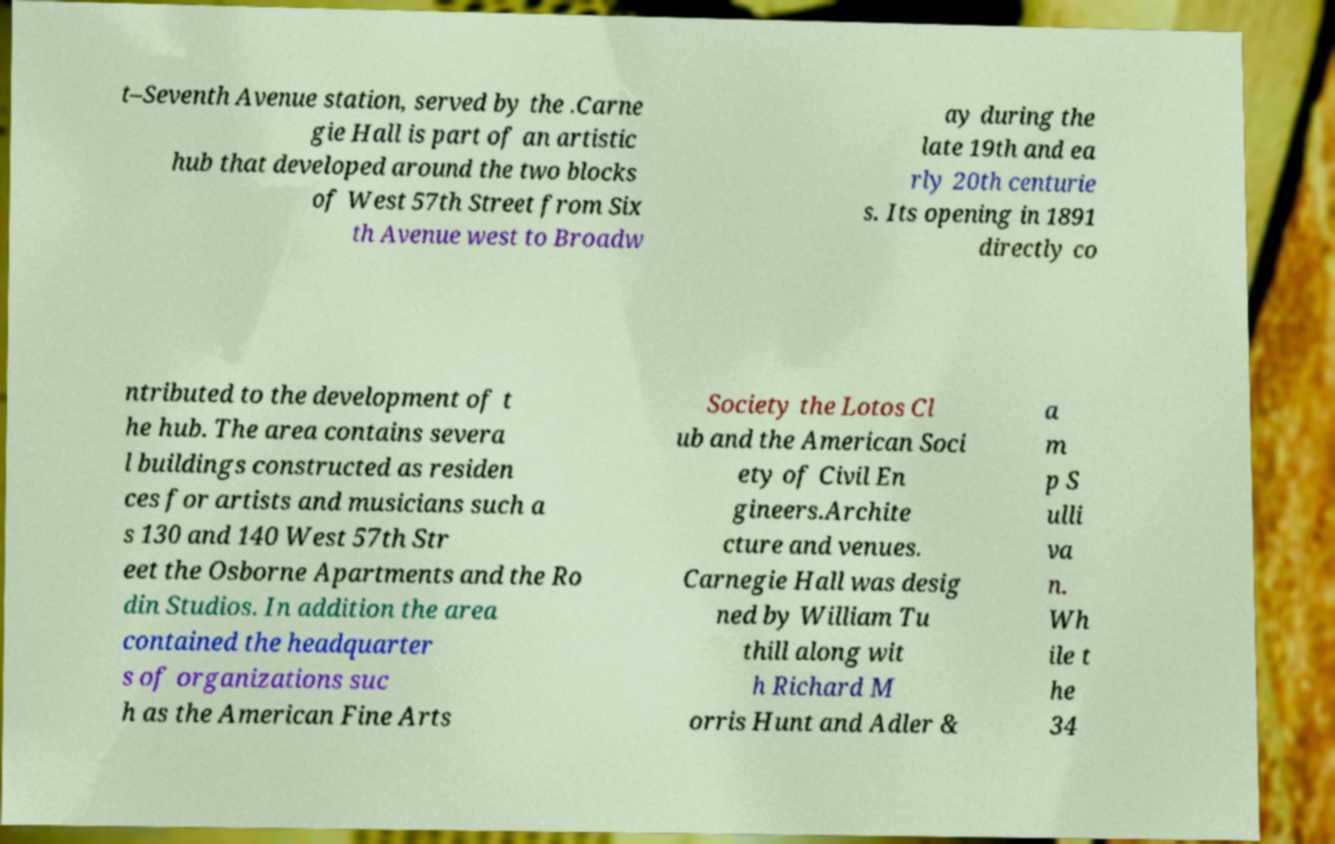Can you read and provide the text displayed in the image?This photo seems to have some interesting text. Can you extract and type it out for me? t–Seventh Avenue station, served by the .Carne gie Hall is part of an artistic hub that developed around the two blocks of West 57th Street from Six th Avenue west to Broadw ay during the late 19th and ea rly 20th centurie s. Its opening in 1891 directly co ntributed to the development of t he hub. The area contains severa l buildings constructed as residen ces for artists and musicians such a s 130 and 140 West 57th Str eet the Osborne Apartments and the Ro din Studios. In addition the area contained the headquarter s of organizations suc h as the American Fine Arts Society the Lotos Cl ub and the American Soci ety of Civil En gineers.Archite cture and venues. Carnegie Hall was desig ned by William Tu thill along wit h Richard M orris Hunt and Adler & a m p S ulli va n. Wh ile t he 34 